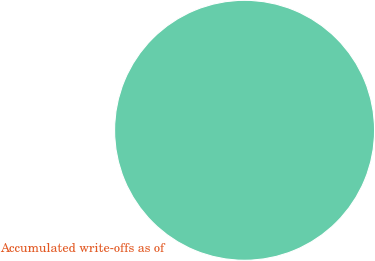Convert chart to OTSL. <chart><loc_0><loc_0><loc_500><loc_500><pie_chart><fcel>Accumulated write-offs as of<nl><fcel>100.0%<nl></chart> 